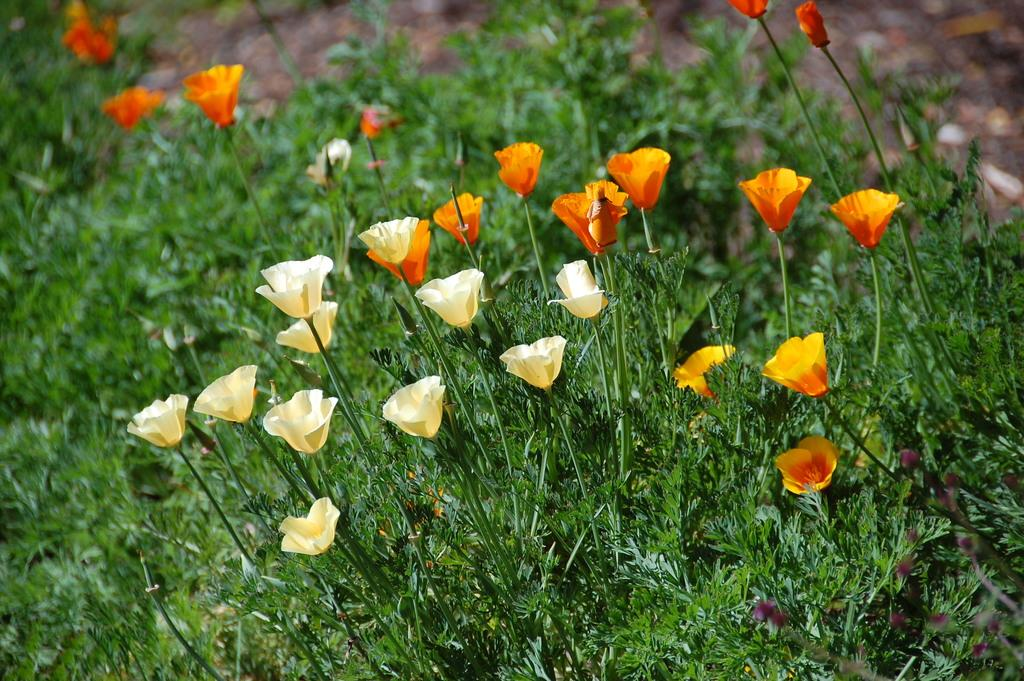What types of living organisms can be seen in the picture? Plants can be seen in the picture. What specific features can be observed on the plants? There are beautiful flowers on the plants. What type of noise can be heard coming from the plants in the image? There is no noise coming from the plants in the image, as plants do not produce sounds. 